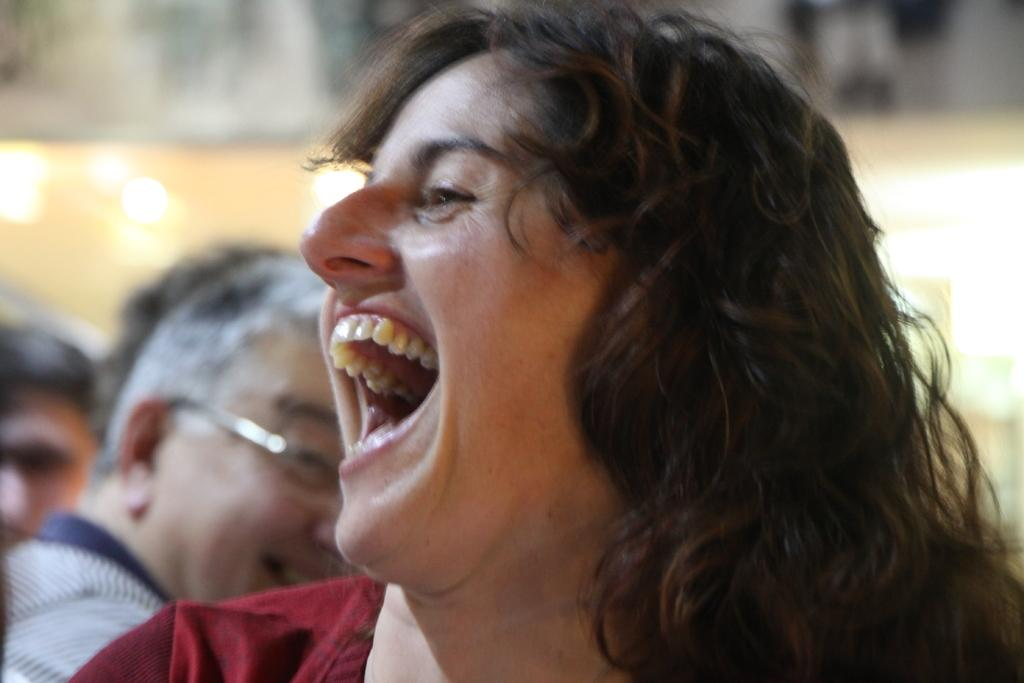Who is present in the image? There is a woman in the image. What is the woman doing in the image? The woman is laughing by opening her mouth. Can you describe the background of the image? There is a man in the background of the image. What is the man doing in the image? The man is also laughing. What type of scientific experiment is being conducted in the image? There is no scientific experiment present in the image; it features a woman and a man laughing. What liquid is being poured in the image? There is no liquid being poured in the image. 